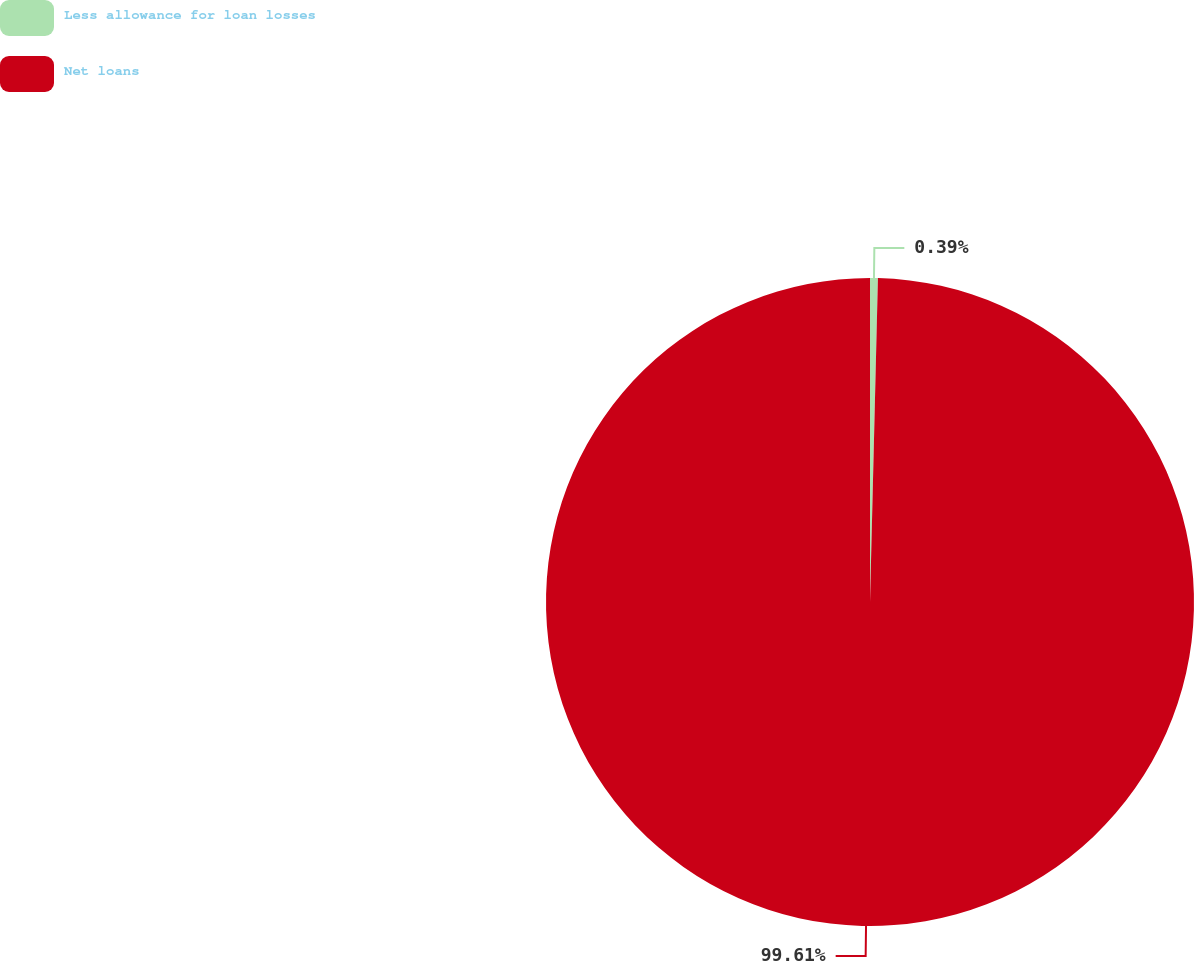Convert chart. <chart><loc_0><loc_0><loc_500><loc_500><pie_chart><fcel>Less allowance for loan losses<fcel>Net loans<nl><fcel>0.39%<fcel>99.61%<nl></chart> 